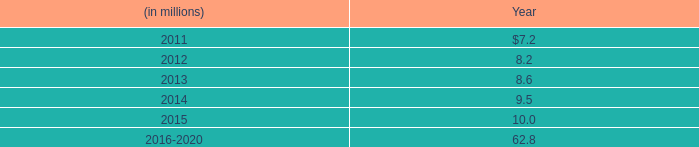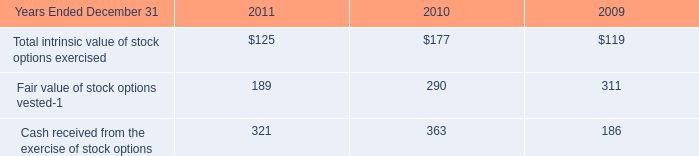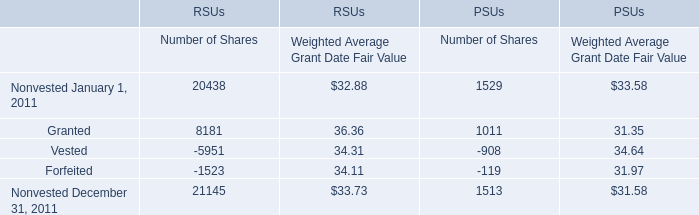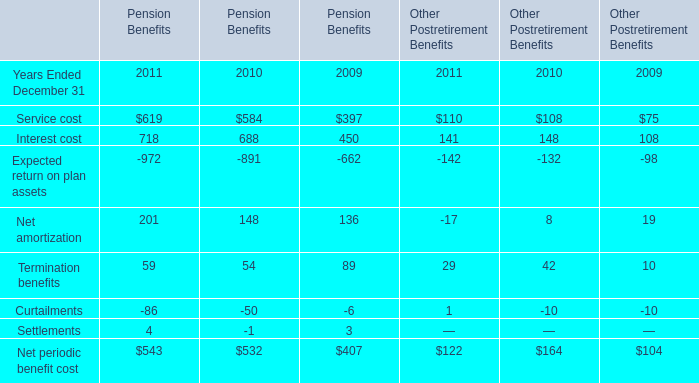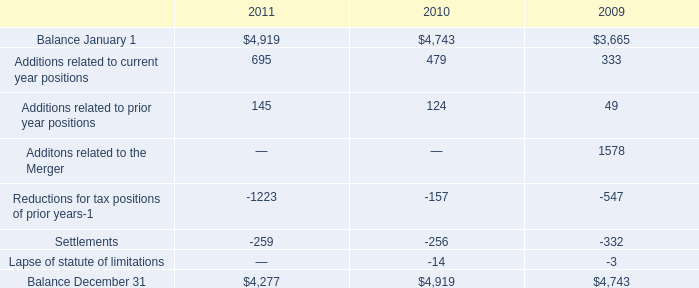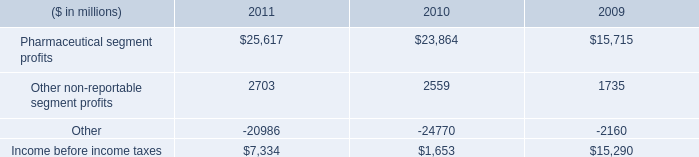Does the average value of Service cost in 2011 greater than that in 2010? 
Answer: Yes. 